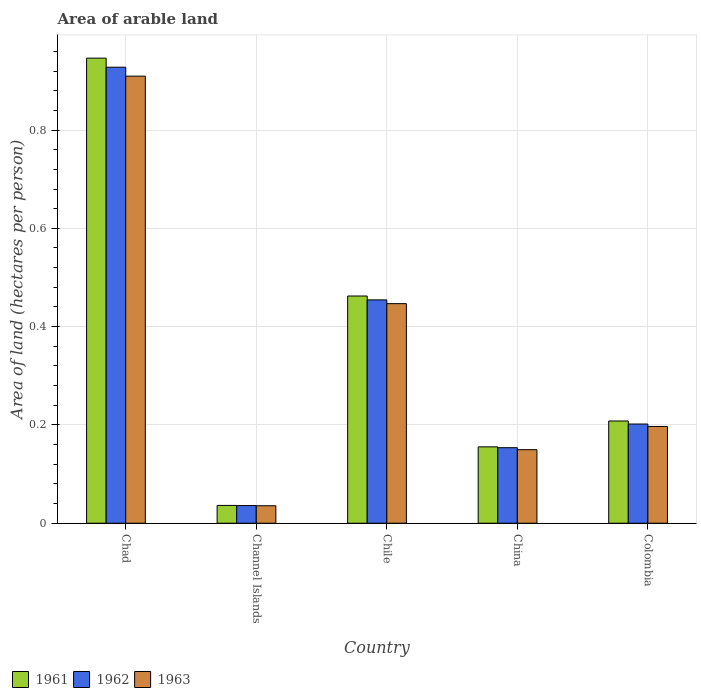How many different coloured bars are there?
Provide a succinct answer. 3. Are the number of bars per tick equal to the number of legend labels?
Ensure brevity in your answer.  Yes. What is the label of the 5th group of bars from the left?
Your answer should be compact. Colombia. What is the total arable land in 1961 in Chad?
Your answer should be compact. 0.95. Across all countries, what is the maximum total arable land in 1962?
Give a very brief answer. 0.93. Across all countries, what is the minimum total arable land in 1961?
Your answer should be very brief. 0.04. In which country was the total arable land in 1963 maximum?
Keep it short and to the point. Chad. In which country was the total arable land in 1961 minimum?
Provide a succinct answer. Channel Islands. What is the total total arable land in 1962 in the graph?
Your answer should be very brief. 1.77. What is the difference between the total arable land in 1962 in Channel Islands and that in Colombia?
Offer a terse response. -0.17. What is the difference between the total arable land in 1962 in Chile and the total arable land in 1961 in Channel Islands?
Give a very brief answer. 0.42. What is the average total arable land in 1963 per country?
Offer a terse response. 0.35. What is the difference between the total arable land of/in 1963 and total arable land of/in 1961 in Chad?
Offer a terse response. -0.04. What is the ratio of the total arable land in 1961 in Chad to that in China?
Provide a succinct answer. 6.09. Is the total arable land in 1963 in Chad less than that in Chile?
Make the answer very short. No. Is the difference between the total arable land in 1963 in Channel Islands and China greater than the difference between the total arable land in 1961 in Channel Islands and China?
Your answer should be compact. Yes. What is the difference between the highest and the second highest total arable land in 1961?
Offer a very short reply. 0.48. What is the difference between the highest and the lowest total arable land in 1961?
Provide a short and direct response. 0.91. In how many countries, is the total arable land in 1962 greater than the average total arable land in 1962 taken over all countries?
Give a very brief answer. 2. Is the sum of the total arable land in 1962 in Channel Islands and Chile greater than the maximum total arable land in 1963 across all countries?
Provide a short and direct response. No. What does the 2nd bar from the left in Channel Islands represents?
Offer a terse response. 1962. How many countries are there in the graph?
Ensure brevity in your answer.  5. What is the difference between two consecutive major ticks on the Y-axis?
Ensure brevity in your answer.  0.2. Are the values on the major ticks of Y-axis written in scientific E-notation?
Ensure brevity in your answer.  No. How many legend labels are there?
Your answer should be compact. 3. What is the title of the graph?
Make the answer very short. Area of arable land. Does "1998" appear as one of the legend labels in the graph?
Your answer should be very brief. No. What is the label or title of the X-axis?
Your answer should be compact. Country. What is the label or title of the Y-axis?
Provide a short and direct response. Area of land (hectares per person). What is the Area of land (hectares per person) in 1961 in Chad?
Offer a very short reply. 0.95. What is the Area of land (hectares per person) of 1962 in Chad?
Your answer should be compact. 0.93. What is the Area of land (hectares per person) in 1963 in Chad?
Provide a short and direct response. 0.91. What is the Area of land (hectares per person) of 1961 in Channel Islands?
Provide a short and direct response. 0.04. What is the Area of land (hectares per person) of 1962 in Channel Islands?
Your answer should be compact. 0.04. What is the Area of land (hectares per person) of 1963 in Channel Islands?
Provide a succinct answer. 0.04. What is the Area of land (hectares per person) in 1961 in Chile?
Keep it short and to the point. 0.46. What is the Area of land (hectares per person) in 1962 in Chile?
Provide a short and direct response. 0.45. What is the Area of land (hectares per person) in 1963 in Chile?
Offer a very short reply. 0.45. What is the Area of land (hectares per person) of 1961 in China?
Offer a terse response. 0.16. What is the Area of land (hectares per person) in 1962 in China?
Offer a very short reply. 0.15. What is the Area of land (hectares per person) in 1963 in China?
Ensure brevity in your answer.  0.15. What is the Area of land (hectares per person) in 1961 in Colombia?
Your answer should be compact. 0.21. What is the Area of land (hectares per person) of 1962 in Colombia?
Keep it short and to the point. 0.2. What is the Area of land (hectares per person) of 1963 in Colombia?
Offer a very short reply. 0.2. Across all countries, what is the maximum Area of land (hectares per person) in 1961?
Keep it short and to the point. 0.95. Across all countries, what is the maximum Area of land (hectares per person) of 1962?
Offer a terse response. 0.93. Across all countries, what is the maximum Area of land (hectares per person) in 1963?
Give a very brief answer. 0.91. Across all countries, what is the minimum Area of land (hectares per person) of 1961?
Offer a terse response. 0.04. Across all countries, what is the minimum Area of land (hectares per person) of 1962?
Ensure brevity in your answer.  0.04. Across all countries, what is the minimum Area of land (hectares per person) in 1963?
Provide a succinct answer. 0.04. What is the total Area of land (hectares per person) in 1961 in the graph?
Ensure brevity in your answer.  1.81. What is the total Area of land (hectares per person) of 1962 in the graph?
Keep it short and to the point. 1.77. What is the total Area of land (hectares per person) of 1963 in the graph?
Make the answer very short. 1.74. What is the difference between the Area of land (hectares per person) in 1961 in Chad and that in Channel Islands?
Your response must be concise. 0.91. What is the difference between the Area of land (hectares per person) in 1962 in Chad and that in Channel Islands?
Offer a very short reply. 0.89. What is the difference between the Area of land (hectares per person) in 1963 in Chad and that in Channel Islands?
Your answer should be compact. 0.87. What is the difference between the Area of land (hectares per person) in 1961 in Chad and that in Chile?
Your answer should be compact. 0.48. What is the difference between the Area of land (hectares per person) in 1962 in Chad and that in Chile?
Your answer should be compact. 0.47. What is the difference between the Area of land (hectares per person) in 1963 in Chad and that in Chile?
Your answer should be very brief. 0.46. What is the difference between the Area of land (hectares per person) of 1961 in Chad and that in China?
Give a very brief answer. 0.79. What is the difference between the Area of land (hectares per person) in 1962 in Chad and that in China?
Give a very brief answer. 0.77. What is the difference between the Area of land (hectares per person) in 1963 in Chad and that in China?
Provide a succinct answer. 0.76. What is the difference between the Area of land (hectares per person) in 1961 in Chad and that in Colombia?
Ensure brevity in your answer.  0.74. What is the difference between the Area of land (hectares per person) in 1962 in Chad and that in Colombia?
Give a very brief answer. 0.73. What is the difference between the Area of land (hectares per person) in 1963 in Chad and that in Colombia?
Your answer should be compact. 0.71. What is the difference between the Area of land (hectares per person) in 1961 in Channel Islands and that in Chile?
Offer a terse response. -0.43. What is the difference between the Area of land (hectares per person) in 1962 in Channel Islands and that in Chile?
Offer a very short reply. -0.42. What is the difference between the Area of land (hectares per person) of 1963 in Channel Islands and that in Chile?
Your answer should be very brief. -0.41. What is the difference between the Area of land (hectares per person) of 1961 in Channel Islands and that in China?
Provide a succinct answer. -0.12. What is the difference between the Area of land (hectares per person) of 1962 in Channel Islands and that in China?
Your answer should be compact. -0.12. What is the difference between the Area of land (hectares per person) of 1963 in Channel Islands and that in China?
Provide a short and direct response. -0.11. What is the difference between the Area of land (hectares per person) in 1961 in Channel Islands and that in Colombia?
Your answer should be compact. -0.17. What is the difference between the Area of land (hectares per person) of 1962 in Channel Islands and that in Colombia?
Make the answer very short. -0.17. What is the difference between the Area of land (hectares per person) of 1963 in Channel Islands and that in Colombia?
Make the answer very short. -0.16. What is the difference between the Area of land (hectares per person) in 1961 in Chile and that in China?
Make the answer very short. 0.31. What is the difference between the Area of land (hectares per person) in 1962 in Chile and that in China?
Offer a terse response. 0.3. What is the difference between the Area of land (hectares per person) of 1963 in Chile and that in China?
Your answer should be very brief. 0.3. What is the difference between the Area of land (hectares per person) of 1961 in Chile and that in Colombia?
Your answer should be very brief. 0.25. What is the difference between the Area of land (hectares per person) in 1962 in Chile and that in Colombia?
Your answer should be compact. 0.25. What is the difference between the Area of land (hectares per person) of 1963 in Chile and that in Colombia?
Your response must be concise. 0.25. What is the difference between the Area of land (hectares per person) in 1961 in China and that in Colombia?
Provide a short and direct response. -0.05. What is the difference between the Area of land (hectares per person) of 1962 in China and that in Colombia?
Offer a terse response. -0.05. What is the difference between the Area of land (hectares per person) of 1963 in China and that in Colombia?
Your answer should be compact. -0.05. What is the difference between the Area of land (hectares per person) of 1961 in Chad and the Area of land (hectares per person) of 1962 in Channel Islands?
Your answer should be very brief. 0.91. What is the difference between the Area of land (hectares per person) in 1961 in Chad and the Area of land (hectares per person) in 1963 in Channel Islands?
Your answer should be very brief. 0.91. What is the difference between the Area of land (hectares per person) in 1962 in Chad and the Area of land (hectares per person) in 1963 in Channel Islands?
Make the answer very short. 0.89. What is the difference between the Area of land (hectares per person) of 1961 in Chad and the Area of land (hectares per person) of 1962 in Chile?
Your answer should be very brief. 0.49. What is the difference between the Area of land (hectares per person) of 1961 in Chad and the Area of land (hectares per person) of 1963 in Chile?
Offer a very short reply. 0.5. What is the difference between the Area of land (hectares per person) in 1962 in Chad and the Area of land (hectares per person) in 1963 in Chile?
Your answer should be compact. 0.48. What is the difference between the Area of land (hectares per person) in 1961 in Chad and the Area of land (hectares per person) in 1962 in China?
Your response must be concise. 0.79. What is the difference between the Area of land (hectares per person) of 1961 in Chad and the Area of land (hectares per person) of 1963 in China?
Your response must be concise. 0.8. What is the difference between the Area of land (hectares per person) of 1962 in Chad and the Area of land (hectares per person) of 1963 in China?
Offer a terse response. 0.78. What is the difference between the Area of land (hectares per person) in 1961 in Chad and the Area of land (hectares per person) in 1962 in Colombia?
Provide a succinct answer. 0.74. What is the difference between the Area of land (hectares per person) in 1961 in Chad and the Area of land (hectares per person) in 1963 in Colombia?
Make the answer very short. 0.75. What is the difference between the Area of land (hectares per person) of 1962 in Chad and the Area of land (hectares per person) of 1963 in Colombia?
Ensure brevity in your answer.  0.73. What is the difference between the Area of land (hectares per person) in 1961 in Channel Islands and the Area of land (hectares per person) in 1962 in Chile?
Give a very brief answer. -0.42. What is the difference between the Area of land (hectares per person) of 1961 in Channel Islands and the Area of land (hectares per person) of 1963 in Chile?
Give a very brief answer. -0.41. What is the difference between the Area of land (hectares per person) of 1962 in Channel Islands and the Area of land (hectares per person) of 1963 in Chile?
Give a very brief answer. -0.41. What is the difference between the Area of land (hectares per person) of 1961 in Channel Islands and the Area of land (hectares per person) of 1962 in China?
Offer a terse response. -0.12. What is the difference between the Area of land (hectares per person) of 1961 in Channel Islands and the Area of land (hectares per person) of 1963 in China?
Your response must be concise. -0.11. What is the difference between the Area of land (hectares per person) in 1962 in Channel Islands and the Area of land (hectares per person) in 1963 in China?
Keep it short and to the point. -0.11. What is the difference between the Area of land (hectares per person) of 1961 in Channel Islands and the Area of land (hectares per person) of 1962 in Colombia?
Your answer should be compact. -0.17. What is the difference between the Area of land (hectares per person) of 1961 in Channel Islands and the Area of land (hectares per person) of 1963 in Colombia?
Offer a terse response. -0.16. What is the difference between the Area of land (hectares per person) of 1962 in Channel Islands and the Area of land (hectares per person) of 1963 in Colombia?
Your response must be concise. -0.16. What is the difference between the Area of land (hectares per person) in 1961 in Chile and the Area of land (hectares per person) in 1962 in China?
Provide a succinct answer. 0.31. What is the difference between the Area of land (hectares per person) in 1961 in Chile and the Area of land (hectares per person) in 1963 in China?
Offer a terse response. 0.31. What is the difference between the Area of land (hectares per person) in 1962 in Chile and the Area of land (hectares per person) in 1963 in China?
Offer a very short reply. 0.3. What is the difference between the Area of land (hectares per person) of 1961 in Chile and the Area of land (hectares per person) of 1962 in Colombia?
Give a very brief answer. 0.26. What is the difference between the Area of land (hectares per person) in 1961 in Chile and the Area of land (hectares per person) in 1963 in Colombia?
Make the answer very short. 0.27. What is the difference between the Area of land (hectares per person) in 1962 in Chile and the Area of land (hectares per person) in 1963 in Colombia?
Ensure brevity in your answer.  0.26. What is the difference between the Area of land (hectares per person) in 1961 in China and the Area of land (hectares per person) in 1962 in Colombia?
Your response must be concise. -0.05. What is the difference between the Area of land (hectares per person) of 1961 in China and the Area of land (hectares per person) of 1963 in Colombia?
Offer a terse response. -0.04. What is the difference between the Area of land (hectares per person) in 1962 in China and the Area of land (hectares per person) in 1963 in Colombia?
Give a very brief answer. -0.04. What is the average Area of land (hectares per person) of 1961 per country?
Make the answer very short. 0.36. What is the average Area of land (hectares per person) in 1962 per country?
Give a very brief answer. 0.35. What is the average Area of land (hectares per person) in 1963 per country?
Make the answer very short. 0.35. What is the difference between the Area of land (hectares per person) of 1961 and Area of land (hectares per person) of 1962 in Chad?
Your answer should be very brief. 0.02. What is the difference between the Area of land (hectares per person) of 1961 and Area of land (hectares per person) of 1963 in Chad?
Provide a short and direct response. 0.04. What is the difference between the Area of land (hectares per person) in 1962 and Area of land (hectares per person) in 1963 in Chad?
Give a very brief answer. 0.02. What is the difference between the Area of land (hectares per person) in 1961 and Area of land (hectares per person) in 1962 in Channel Islands?
Give a very brief answer. 0. What is the difference between the Area of land (hectares per person) in 1961 and Area of land (hectares per person) in 1963 in Channel Islands?
Provide a short and direct response. 0. What is the difference between the Area of land (hectares per person) in 1962 and Area of land (hectares per person) in 1963 in Channel Islands?
Your answer should be very brief. 0. What is the difference between the Area of land (hectares per person) of 1961 and Area of land (hectares per person) of 1962 in Chile?
Make the answer very short. 0.01. What is the difference between the Area of land (hectares per person) in 1961 and Area of land (hectares per person) in 1963 in Chile?
Offer a terse response. 0.02. What is the difference between the Area of land (hectares per person) of 1962 and Area of land (hectares per person) of 1963 in Chile?
Your response must be concise. 0.01. What is the difference between the Area of land (hectares per person) of 1961 and Area of land (hectares per person) of 1962 in China?
Provide a short and direct response. 0. What is the difference between the Area of land (hectares per person) in 1961 and Area of land (hectares per person) in 1963 in China?
Your answer should be very brief. 0.01. What is the difference between the Area of land (hectares per person) in 1962 and Area of land (hectares per person) in 1963 in China?
Offer a terse response. 0. What is the difference between the Area of land (hectares per person) of 1961 and Area of land (hectares per person) of 1962 in Colombia?
Provide a succinct answer. 0.01. What is the difference between the Area of land (hectares per person) in 1961 and Area of land (hectares per person) in 1963 in Colombia?
Provide a short and direct response. 0.01. What is the difference between the Area of land (hectares per person) of 1962 and Area of land (hectares per person) of 1963 in Colombia?
Offer a terse response. 0.01. What is the ratio of the Area of land (hectares per person) in 1961 in Chad to that in Channel Islands?
Your answer should be very brief. 26.12. What is the ratio of the Area of land (hectares per person) in 1962 in Chad to that in Channel Islands?
Make the answer very short. 25.85. What is the ratio of the Area of land (hectares per person) in 1963 in Chad to that in Channel Islands?
Your answer should be very brief. 25.61. What is the ratio of the Area of land (hectares per person) in 1961 in Chad to that in Chile?
Offer a terse response. 2.05. What is the ratio of the Area of land (hectares per person) in 1962 in Chad to that in Chile?
Offer a very short reply. 2.04. What is the ratio of the Area of land (hectares per person) in 1963 in Chad to that in Chile?
Give a very brief answer. 2.04. What is the ratio of the Area of land (hectares per person) of 1961 in Chad to that in China?
Your answer should be very brief. 6.09. What is the ratio of the Area of land (hectares per person) of 1962 in Chad to that in China?
Offer a very short reply. 6.04. What is the ratio of the Area of land (hectares per person) in 1963 in Chad to that in China?
Your answer should be very brief. 6.08. What is the ratio of the Area of land (hectares per person) of 1961 in Chad to that in Colombia?
Offer a terse response. 4.55. What is the ratio of the Area of land (hectares per person) in 1962 in Chad to that in Colombia?
Offer a very short reply. 4.6. What is the ratio of the Area of land (hectares per person) of 1963 in Chad to that in Colombia?
Offer a terse response. 4.62. What is the ratio of the Area of land (hectares per person) in 1961 in Channel Islands to that in Chile?
Provide a succinct answer. 0.08. What is the ratio of the Area of land (hectares per person) of 1962 in Channel Islands to that in Chile?
Offer a very short reply. 0.08. What is the ratio of the Area of land (hectares per person) of 1963 in Channel Islands to that in Chile?
Keep it short and to the point. 0.08. What is the ratio of the Area of land (hectares per person) of 1961 in Channel Islands to that in China?
Keep it short and to the point. 0.23. What is the ratio of the Area of land (hectares per person) of 1962 in Channel Islands to that in China?
Your answer should be very brief. 0.23. What is the ratio of the Area of land (hectares per person) in 1963 in Channel Islands to that in China?
Make the answer very short. 0.24. What is the ratio of the Area of land (hectares per person) in 1961 in Channel Islands to that in Colombia?
Provide a succinct answer. 0.17. What is the ratio of the Area of land (hectares per person) of 1962 in Channel Islands to that in Colombia?
Keep it short and to the point. 0.18. What is the ratio of the Area of land (hectares per person) in 1963 in Channel Islands to that in Colombia?
Give a very brief answer. 0.18. What is the ratio of the Area of land (hectares per person) in 1961 in Chile to that in China?
Provide a succinct answer. 2.98. What is the ratio of the Area of land (hectares per person) of 1962 in Chile to that in China?
Keep it short and to the point. 2.96. What is the ratio of the Area of land (hectares per person) in 1963 in Chile to that in China?
Your answer should be very brief. 2.99. What is the ratio of the Area of land (hectares per person) of 1961 in Chile to that in Colombia?
Offer a very short reply. 2.22. What is the ratio of the Area of land (hectares per person) of 1962 in Chile to that in Colombia?
Your answer should be compact. 2.25. What is the ratio of the Area of land (hectares per person) of 1963 in Chile to that in Colombia?
Ensure brevity in your answer.  2.27. What is the ratio of the Area of land (hectares per person) in 1961 in China to that in Colombia?
Offer a very short reply. 0.75. What is the ratio of the Area of land (hectares per person) of 1962 in China to that in Colombia?
Provide a succinct answer. 0.76. What is the ratio of the Area of land (hectares per person) in 1963 in China to that in Colombia?
Give a very brief answer. 0.76. What is the difference between the highest and the second highest Area of land (hectares per person) in 1961?
Your response must be concise. 0.48. What is the difference between the highest and the second highest Area of land (hectares per person) in 1962?
Offer a very short reply. 0.47. What is the difference between the highest and the second highest Area of land (hectares per person) in 1963?
Your response must be concise. 0.46. What is the difference between the highest and the lowest Area of land (hectares per person) of 1961?
Offer a very short reply. 0.91. What is the difference between the highest and the lowest Area of land (hectares per person) in 1962?
Provide a short and direct response. 0.89. What is the difference between the highest and the lowest Area of land (hectares per person) of 1963?
Make the answer very short. 0.87. 